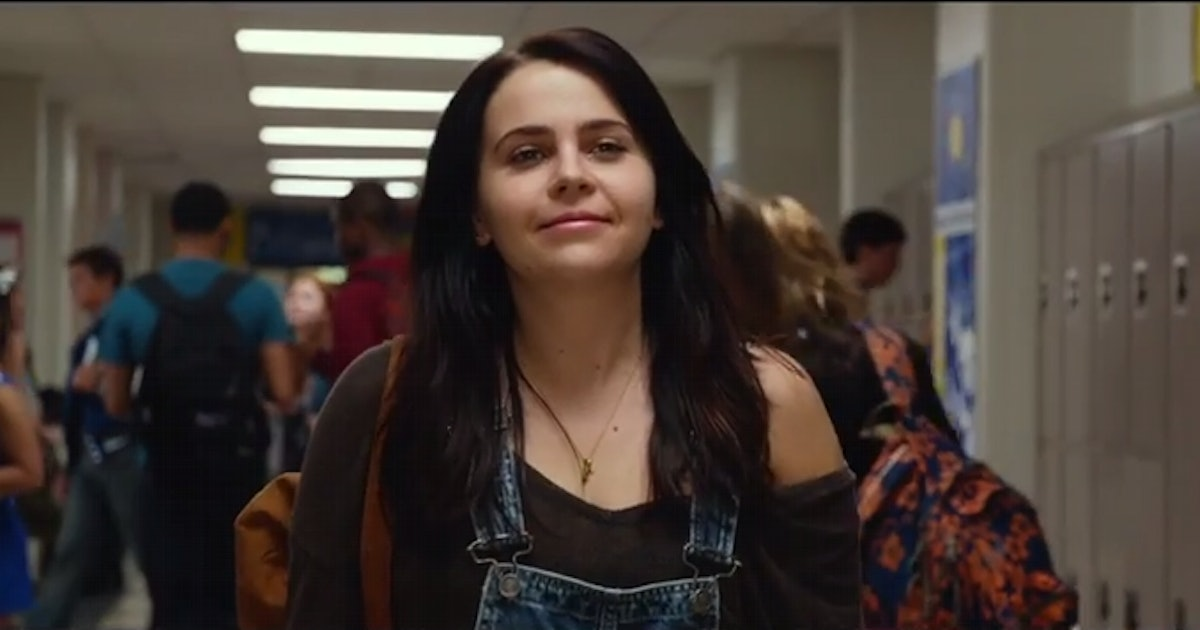What is this photo about'? In this image, actress Mae Whitman is captured in a scene from a movie or TV show. She is seen strolling down a bustling high school hallway, her gaze fixed directly on the camera, a slight smile playing on her lips. Dressed in a casual ensemble of a brown cardigan over a black tank top and blue overalls, she exudes an air of relaxed confidence. A backpack is casually slung over one shoulder, suggesting she's in transit between classes. The hallway is filled with other students, all moving in the opposite direction, adding to the sense of motion and activity in the scene. 